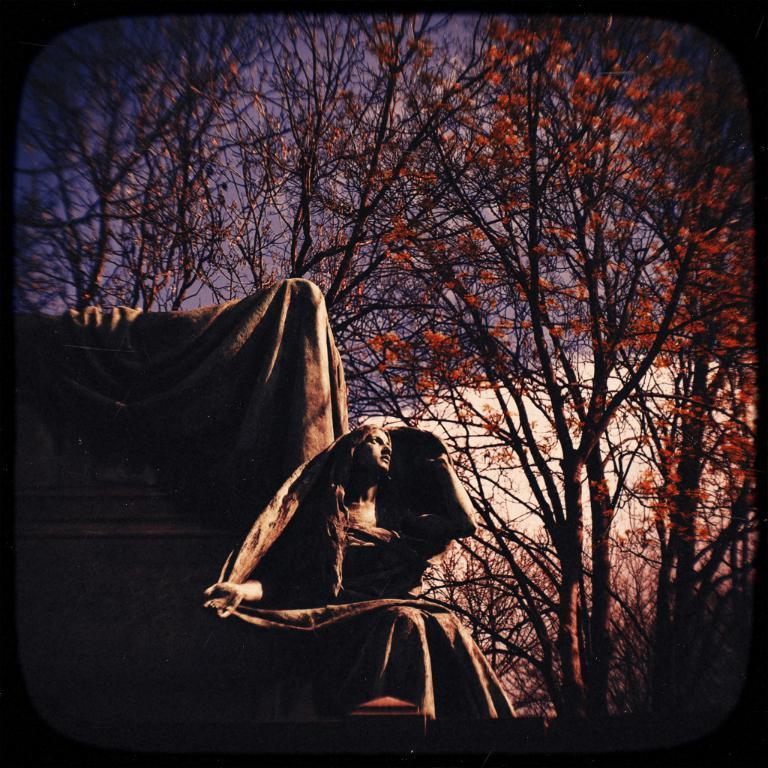Please provide a concise description of this image. In this picture there is a statue of a woman and there are trees which has orange color flowers on it in the background. 